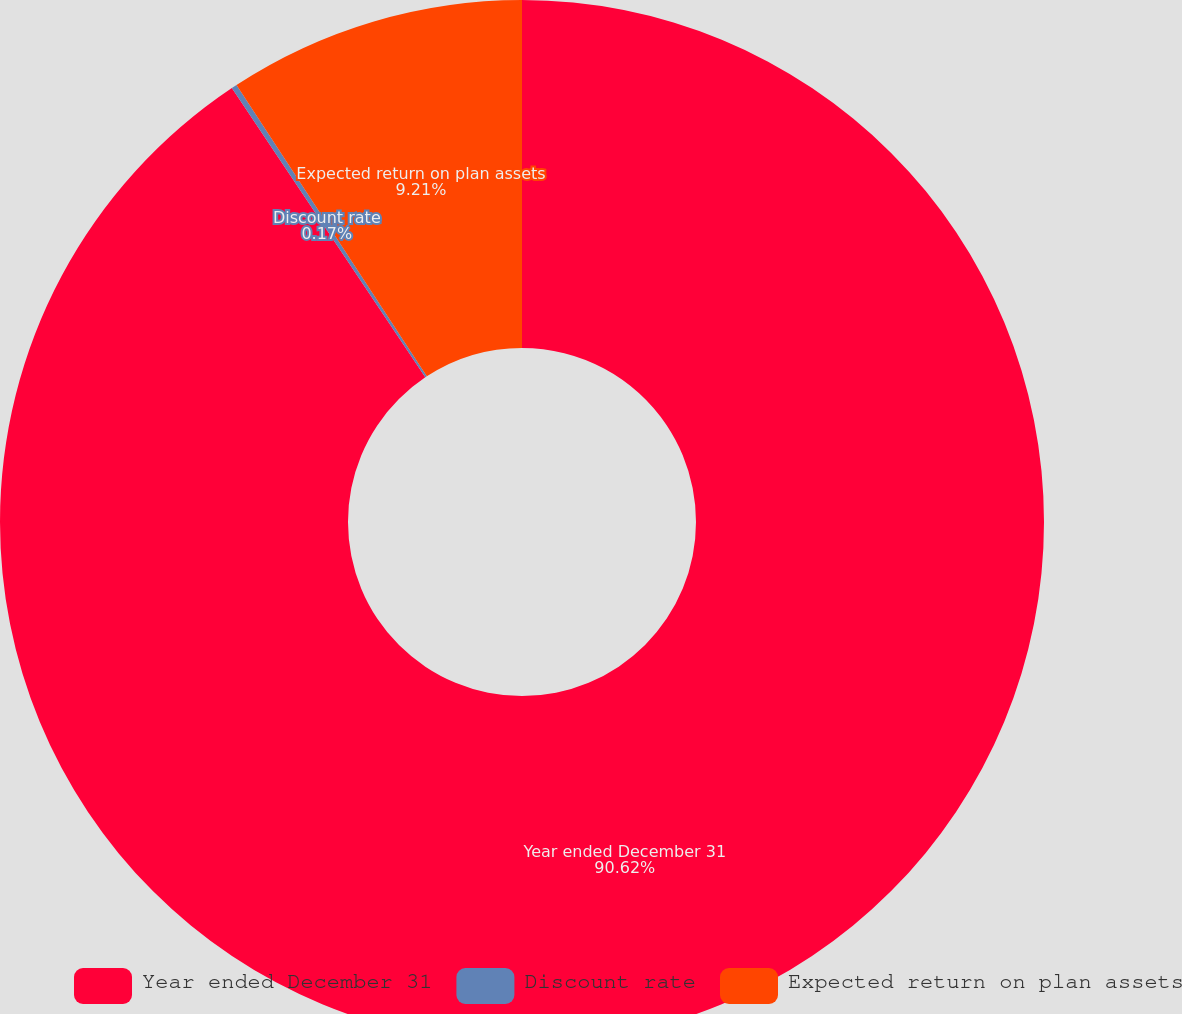<chart> <loc_0><loc_0><loc_500><loc_500><pie_chart><fcel>Year ended December 31<fcel>Discount rate<fcel>Expected return on plan assets<nl><fcel>90.62%<fcel>0.17%<fcel>9.21%<nl></chart> 